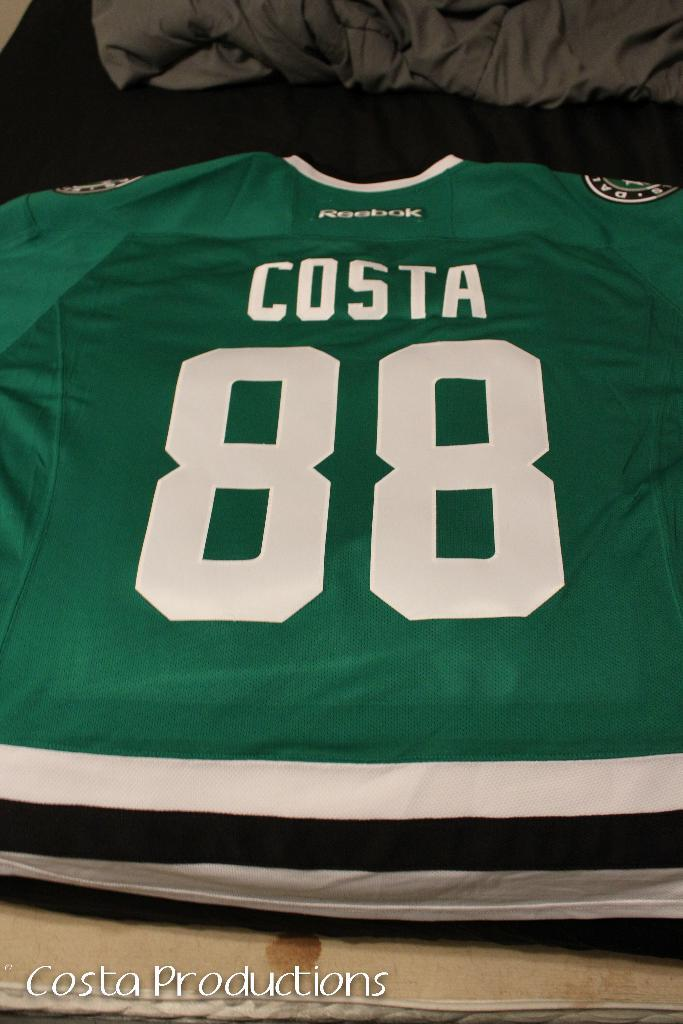<image>
Present a compact description of the photo's key features. A green sports jersey made by Reebok with the name Costa and number 88 is featured. 